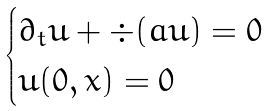Convert formula to latex. <formula><loc_0><loc_0><loc_500><loc_500>\begin{cases} \partial _ { t } u + \div ( a u ) = 0 \\ u ( 0 , x ) = 0 \end{cases}</formula> 